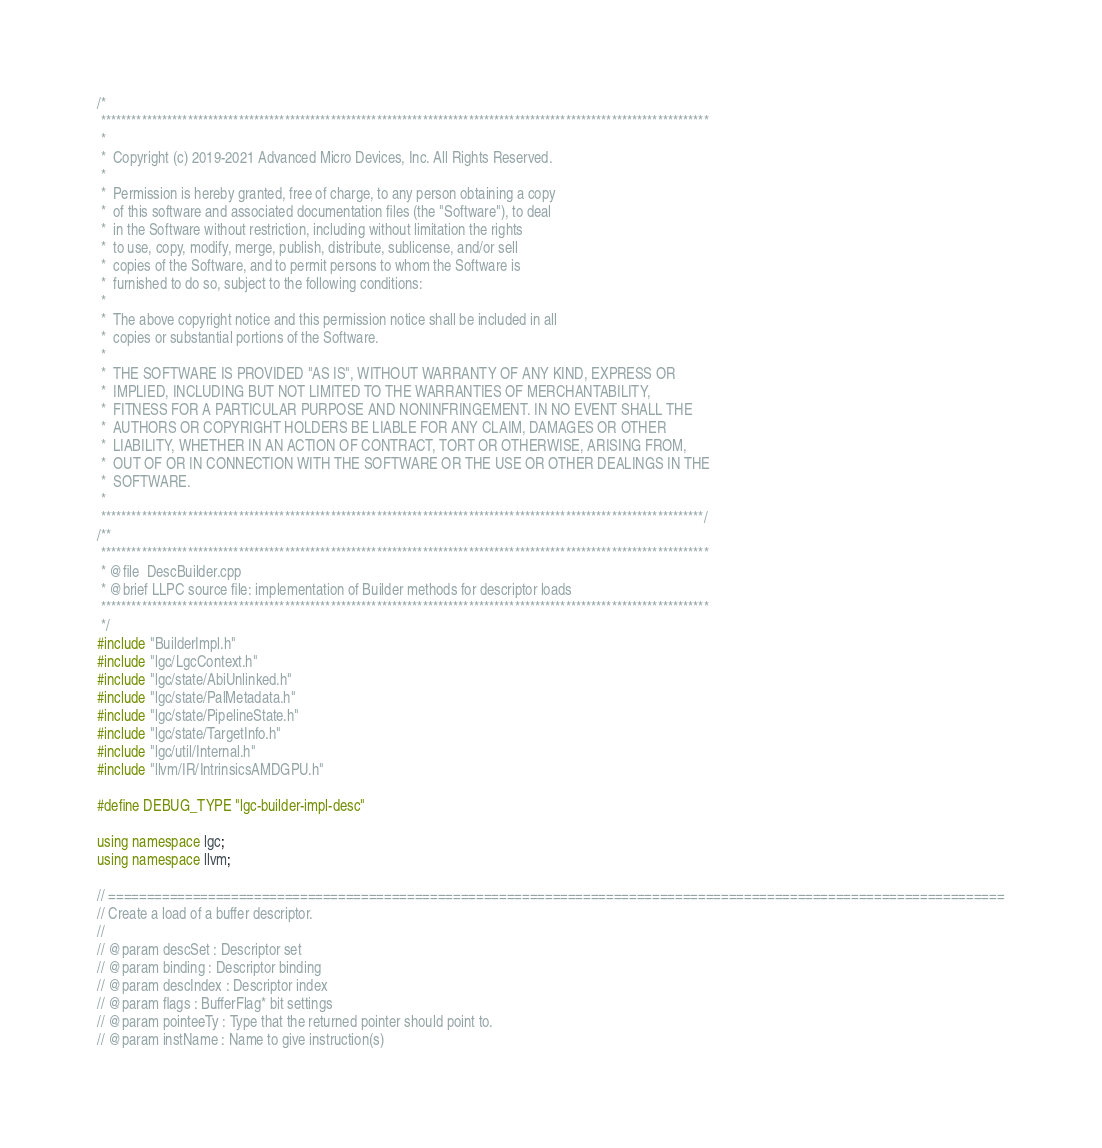Convert code to text. <code><loc_0><loc_0><loc_500><loc_500><_C++_>/*
 ***********************************************************************************************************************
 *
 *  Copyright (c) 2019-2021 Advanced Micro Devices, Inc. All Rights Reserved.
 *
 *  Permission is hereby granted, free of charge, to any person obtaining a copy
 *  of this software and associated documentation files (the "Software"), to deal
 *  in the Software without restriction, including without limitation the rights
 *  to use, copy, modify, merge, publish, distribute, sublicense, and/or sell
 *  copies of the Software, and to permit persons to whom the Software is
 *  furnished to do so, subject to the following conditions:
 *
 *  The above copyright notice and this permission notice shall be included in all
 *  copies or substantial portions of the Software.
 *
 *  THE SOFTWARE IS PROVIDED "AS IS", WITHOUT WARRANTY OF ANY KIND, EXPRESS OR
 *  IMPLIED, INCLUDING BUT NOT LIMITED TO THE WARRANTIES OF MERCHANTABILITY,
 *  FITNESS FOR A PARTICULAR PURPOSE AND NONINFRINGEMENT. IN NO EVENT SHALL THE
 *  AUTHORS OR COPYRIGHT HOLDERS BE LIABLE FOR ANY CLAIM, DAMAGES OR OTHER
 *  LIABILITY, WHETHER IN AN ACTION OF CONTRACT, TORT OR OTHERWISE, ARISING FROM,
 *  OUT OF OR IN CONNECTION WITH THE SOFTWARE OR THE USE OR OTHER DEALINGS IN THE
 *  SOFTWARE.
 *
 **********************************************************************************************************************/
/**
 ***********************************************************************************************************************
 * @file  DescBuilder.cpp
 * @brief LLPC source file: implementation of Builder methods for descriptor loads
 ***********************************************************************************************************************
 */
#include "BuilderImpl.h"
#include "lgc/LgcContext.h"
#include "lgc/state/AbiUnlinked.h"
#include "lgc/state/PalMetadata.h"
#include "lgc/state/PipelineState.h"
#include "lgc/state/TargetInfo.h"
#include "lgc/util/Internal.h"
#include "llvm/IR/IntrinsicsAMDGPU.h"

#define DEBUG_TYPE "lgc-builder-impl-desc"

using namespace lgc;
using namespace llvm;

// =====================================================================================================================
// Create a load of a buffer descriptor.
//
// @param descSet : Descriptor set
// @param binding : Descriptor binding
// @param descIndex : Descriptor index
// @param flags : BufferFlag* bit settings
// @param pointeeTy : Type that the returned pointer should point to.
// @param instName : Name to give instruction(s)</code> 